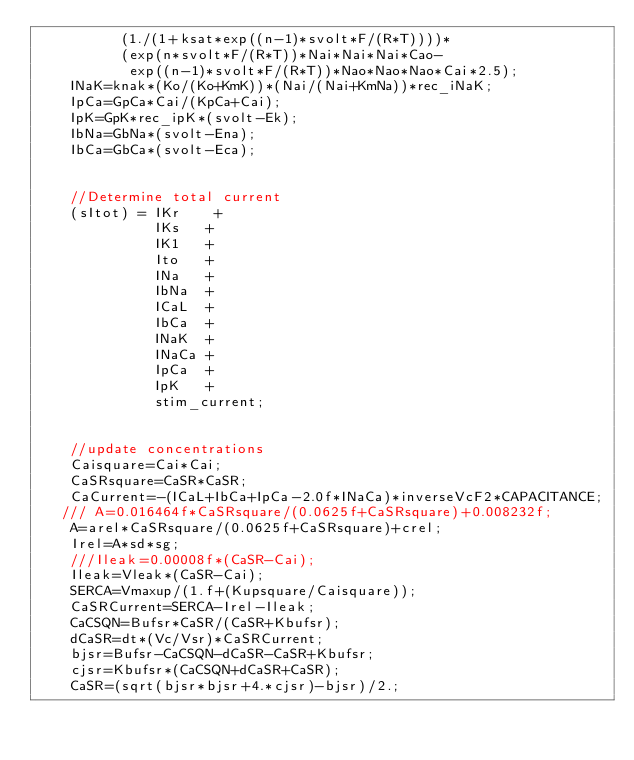<code> <loc_0><loc_0><loc_500><loc_500><_Cuda_>          (1./(1+ksat*exp((n-1)*svolt*F/(R*T))))*
          (exp(n*svolt*F/(R*T))*Nai*Nai*Nai*Cao-
           exp((n-1)*svolt*F/(R*T))*Nao*Nao*Nao*Cai*2.5);
    INaK=knak*(Ko/(Ko+KmK))*(Nai/(Nai+KmNa))*rec_iNaK;
    IpCa=GpCa*Cai/(KpCa+Cai);
    IpK=GpK*rec_ipK*(svolt-Ek);
    IbNa=GbNa*(svolt-Ena);
    IbCa=GbCa*(svolt-Eca);


    //Determine total current
    (sItot) = IKr    +
              IKs   +
              IK1   +
              Ito   +
              INa   +
              IbNa  +
              ICaL  +
              IbCa  +
              INaK  +
              INaCa +
              IpCa  +
              IpK   +
              stim_current;


    //update concentrations
    Caisquare=Cai*Cai;
    CaSRsquare=CaSR*CaSR;
    CaCurrent=-(ICaL+IbCa+IpCa-2.0f*INaCa)*inverseVcF2*CAPACITANCE;
   /// A=0.016464f*CaSRsquare/(0.0625f+CaSRsquare)+0.008232f;
    A=arel*CaSRsquare/(0.0625f+CaSRsquare)+crel;
    Irel=A*sd*sg;
    ///Ileak=0.00008f*(CaSR-Cai);
    Ileak=Vleak*(CaSR-Cai);
    SERCA=Vmaxup/(1.f+(Kupsquare/Caisquare));
    CaSRCurrent=SERCA-Irel-Ileak;
    CaCSQN=Bufsr*CaSR/(CaSR+Kbufsr);
    dCaSR=dt*(Vc/Vsr)*CaSRCurrent;
    bjsr=Bufsr-CaCSQN-dCaSR-CaSR+Kbufsr;
    cjsr=Kbufsr*(CaCSQN+dCaSR+CaSR);
    CaSR=(sqrt(bjsr*bjsr+4.*cjsr)-bjsr)/2.;</code> 